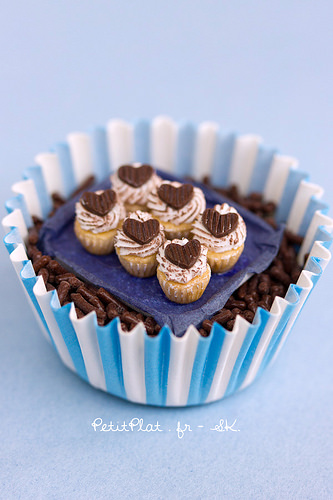<image>
Is there a cake on the cup? Yes. Looking at the image, I can see the cake is positioned on top of the cup, with the cup providing support. 